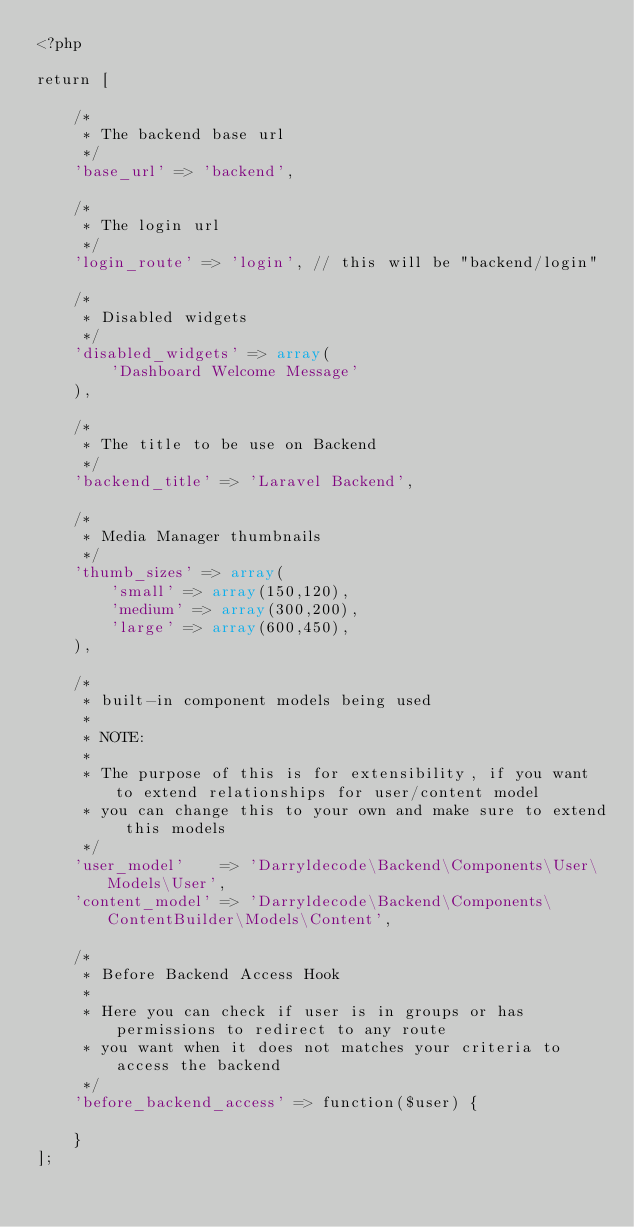<code> <loc_0><loc_0><loc_500><loc_500><_PHP_><?php

return [

    /*
     * The backend base url
     */
    'base_url' => 'backend',

    /*
     * The login url
     */
    'login_route' => 'login', // this will be "backend/login"

    /*
     * Disabled widgets
     */
    'disabled_widgets' => array(
        'Dashboard Welcome Message'
    ),

    /*
     * The title to be use on Backend
     */
    'backend_title' => 'Laravel Backend',

    /*
     * Media Manager thumbnails
     */
    'thumb_sizes' => array(
        'small' => array(150,120),
        'medium' => array(300,200),
        'large' => array(600,450),
    ),

    /*
     * built-in component models being used
     *
     * NOTE:
     *
     * The purpose of this is for extensibility, if you want to extend relationships for user/content model
     * you can change this to your own and make sure to extend this models
     */
    'user_model'    => 'Darryldecode\Backend\Components\User\Models\User',
    'content_model' => 'Darryldecode\Backend\Components\ContentBuilder\Models\Content',

    /*
     * Before Backend Access Hook
     *
     * Here you can check if user is in groups or has permissions to redirect to any route
     * you want when it does not matches your criteria to access the backend
     */
    'before_backend_access' => function($user) {

    }
];</code> 